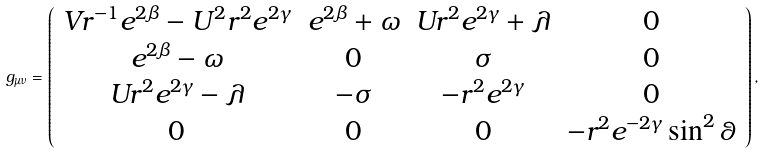<formula> <loc_0><loc_0><loc_500><loc_500>g _ { \mu \nu } = \left ( \begin{array} { c c c c } V r ^ { - 1 } e ^ { 2 \beta } - U ^ { 2 } r ^ { 2 } e ^ { 2 \gamma } & e ^ { 2 \beta } + \omega & U r ^ { 2 } e ^ { 2 \gamma } + \lambda & 0 \\ e ^ { 2 \beta } - \omega & 0 & \sigma & 0 \\ U r ^ { 2 } e ^ { 2 \gamma } - \lambda & - \sigma & - r ^ { 2 } e ^ { 2 \gamma } & 0 \\ 0 & 0 & 0 & - r ^ { 2 } e ^ { - 2 \gamma } \sin ^ { 2 } \theta \end{array} \right ) ,</formula> 